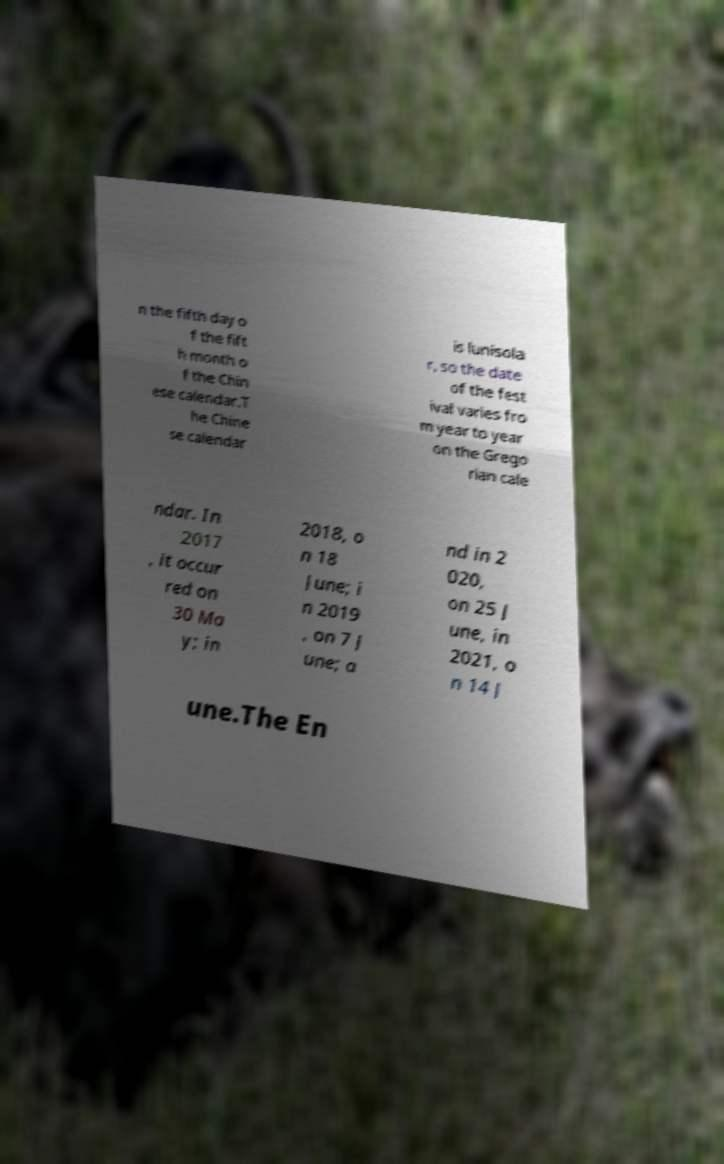What messages or text are displayed in this image? I need them in a readable, typed format. n the fifth day o f the fift h month o f the Chin ese calendar.T he Chine se calendar is lunisola r, so the date of the fest ival varies fro m year to year on the Grego rian cale ndar. In 2017 , it occur red on 30 Ma y; in 2018, o n 18 June; i n 2019 , on 7 J une; a nd in 2 020, on 25 J une, in 2021, o n 14 J une.The En 